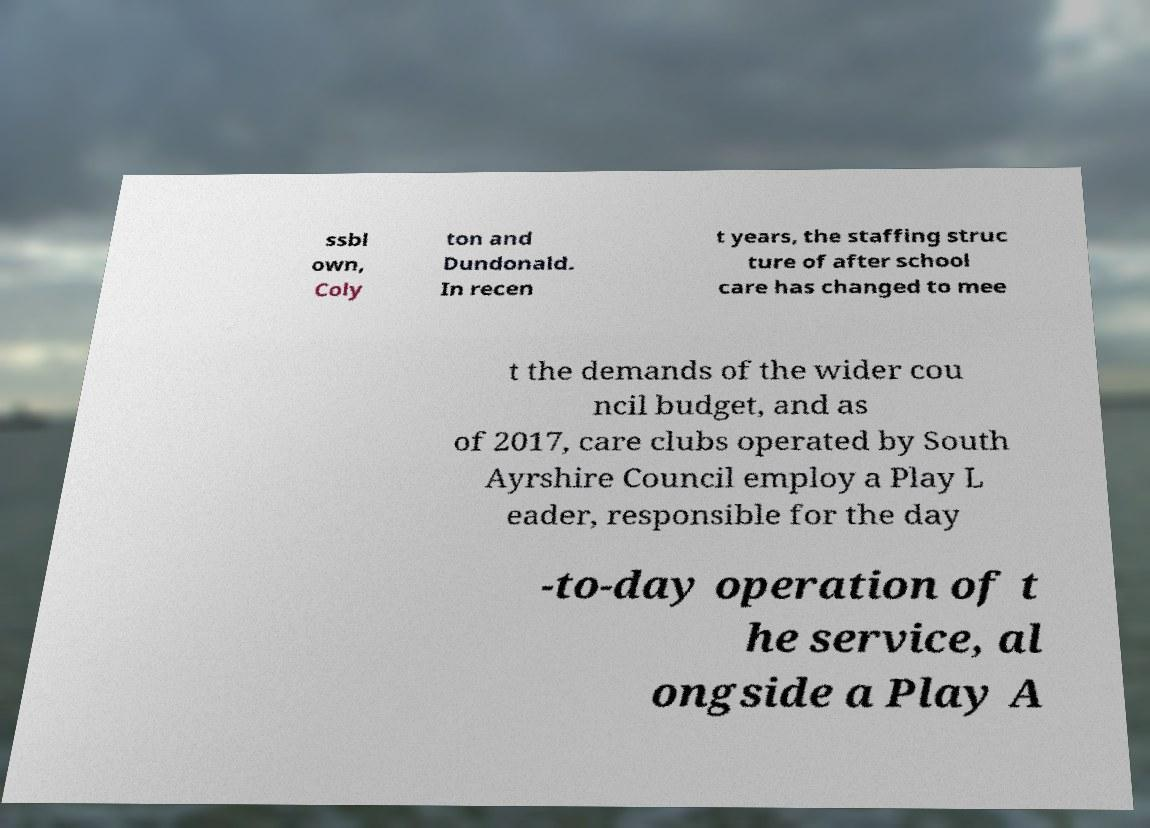Can you accurately transcribe the text from the provided image for me? ssbl own, Coly ton and Dundonald. In recen t years, the staffing struc ture of after school care has changed to mee t the demands of the wider cou ncil budget, and as of 2017, care clubs operated by South Ayrshire Council employ a Play L eader, responsible for the day -to-day operation of t he service, al ongside a Play A 